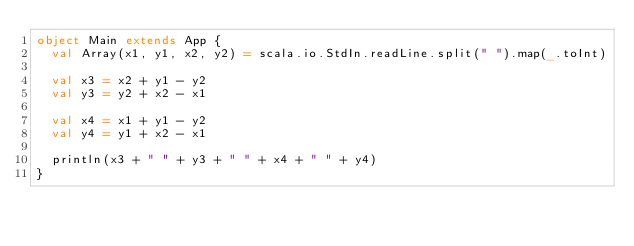<code> <loc_0><loc_0><loc_500><loc_500><_Scala_>object Main extends App {
	val Array(x1, y1, x2, y2) = scala.io.StdIn.readLine.split(" ").map(_.toInt)
	
	val x3 = x2 + y1 - y2 
	val y3 = y2 + x2 - x1

	val x4 = x1 + y1 - y2
	val y4 = y1 + x2 - x1

	println(x3 + " " + y3 + " " + x4 + " " + y4)
}</code> 